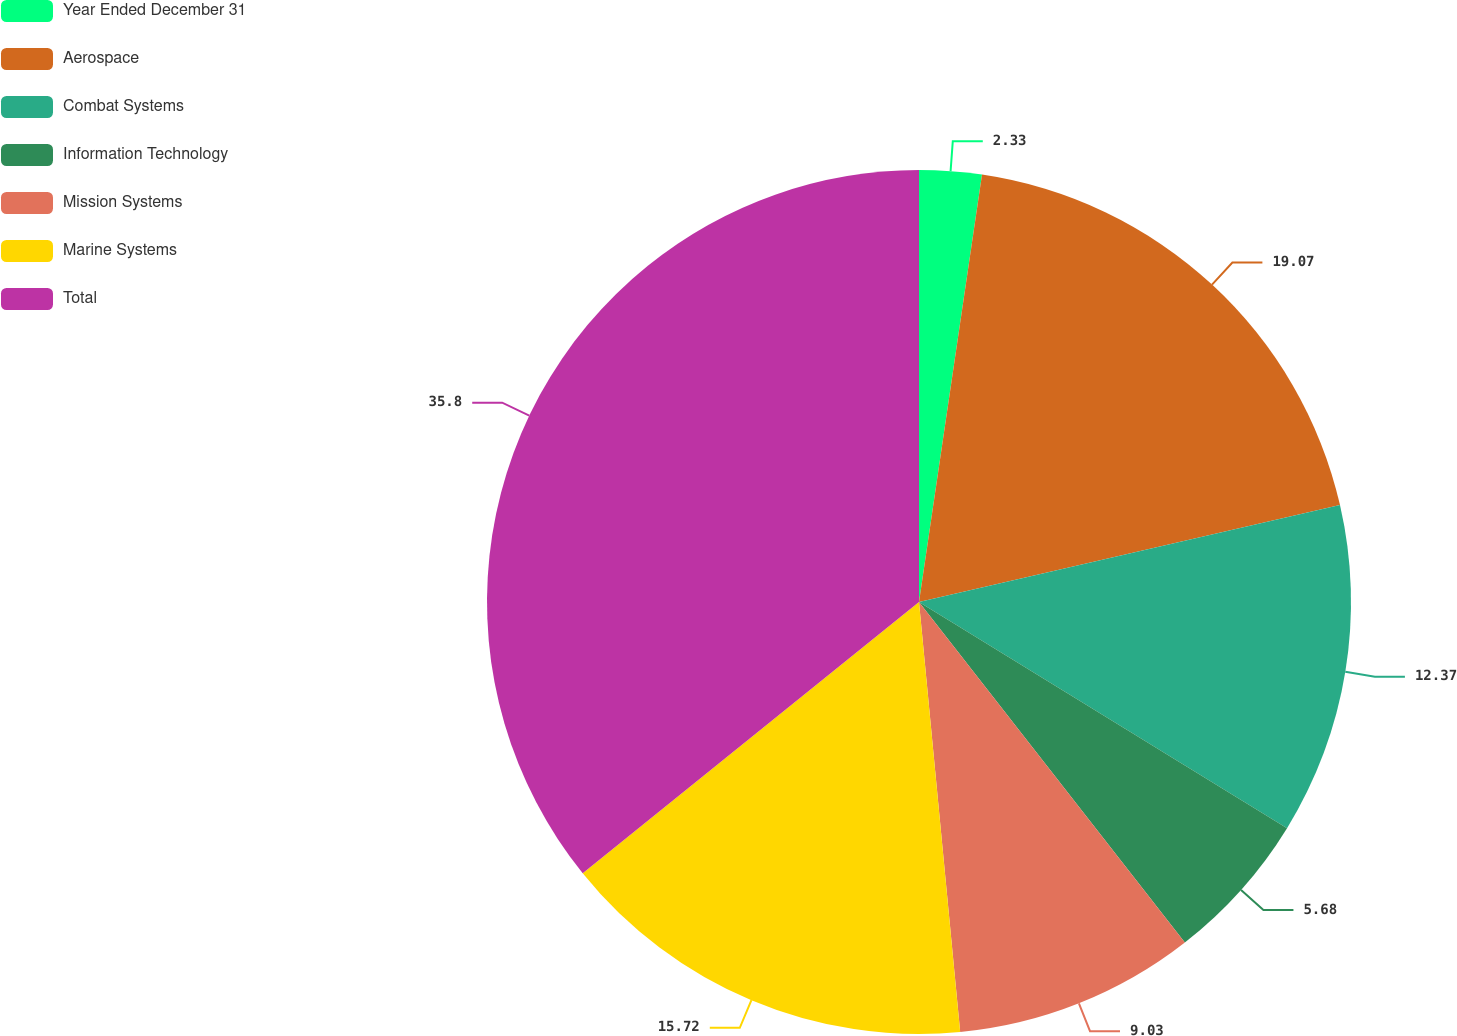Convert chart. <chart><loc_0><loc_0><loc_500><loc_500><pie_chart><fcel>Year Ended December 31<fcel>Aerospace<fcel>Combat Systems<fcel>Information Technology<fcel>Mission Systems<fcel>Marine Systems<fcel>Total<nl><fcel>2.33%<fcel>19.07%<fcel>12.37%<fcel>5.68%<fcel>9.03%<fcel>15.72%<fcel>35.8%<nl></chart> 